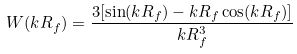<formula> <loc_0><loc_0><loc_500><loc_500>W ( k R _ { f } ) = \frac { 3 [ \sin ( k R _ { f } ) - k R _ { f } \cos ( k R _ { f } ) ] } { k R _ { f } ^ { 3 } }</formula> 